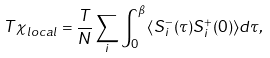<formula> <loc_0><loc_0><loc_500><loc_500>T \chi _ { l o c a l } = \frac { T } { N } \sum _ { i } \int _ { 0 } ^ { \beta } { \langle S ^ { - } _ { i } ( \tau ) S ^ { + } _ { i } ( 0 ) \rangle d \tau } ,</formula> 